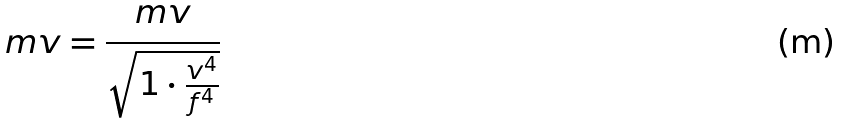<formula> <loc_0><loc_0><loc_500><loc_500>m v = \frac { m v } { \sqrt { 1 \cdot \frac { v ^ { 4 } } { f ^ { 4 } } } }</formula> 